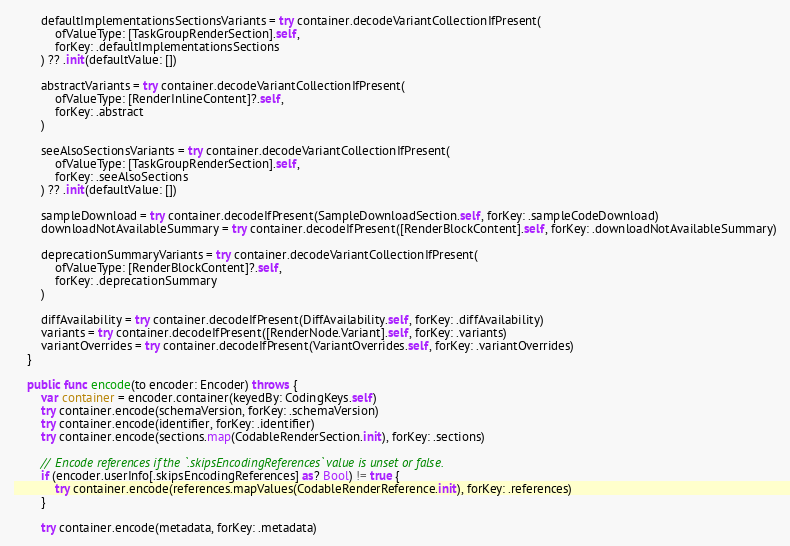Convert code to text. <code><loc_0><loc_0><loc_500><loc_500><_Swift_>        defaultImplementationsSectionsVariants = try container.decodeVariantCollectionIfPresent(
            ofValueType: [TaskGroupRenderSection].self,
            forKey: .defaultImplementationsSections
        ) ?? .init(defaultValue: [])
        
        abstractVariants = try container.decodeVariantCollectionIfPresent(
            ofValueType: [RenderInlineContent]?.self,
            forKey: .abstract
        )
        
        seeAlsoSectionsVariants = try container.decodeVariantCollectionIfPresent(
            ofValueType: [TaskGroupRenderSection].self,
            forKey: .seeAlsoSections
        ) ?? .init(defaultValue: [])
        
        sampleDownload = try container.decodeIfPresent(SampleDownloadSection.self, forKey: .sampleCodeDownload)
        downloadNotAvailableSummary = try container.decodeIfPresent([RenderBlockContent].self, forKey: .downloadNotAvailableSummary)
        
        deprecationSummaryVariants = try container.decodeVariantCollectionIfPresent(
            ofValueType: [RenderBlockContent]?.self,
            forKey: .deprecationSummary
        )
        
        diffAvailability = try container.decodeIfPresent(DiffAvailability.self, forKey: .diffAvailability)
        variants = try container.decodeIfPresent([RenderNode.Variant].self, forKey: .variants)
        variantOverrides = try container.decodeIfPresent(VariantOverrides.self, forKey: .variantOverrides)
    }
    
    public func encode(to encoder: Encoder) throws {
        var container = encoder.container(keyedBy: CodingKeys.self)
        try container.encode(schemaVersion, forKey: .schemaVersion)
        try container.encode(identifier, forKey: .identifier)
        try container.encode(sections.map(CodableRenderSection.init), forKey: .sections)
        
        // Encode references if the `.skipsEncodingReferences` value is unset or false.
        if (encoder.userInfo[.skipsEncodingReferences] as? Bool) != true {
            try container.encode(references.mapValues(CodableRenderReference.init), forKey: .references)
        }
        
        try container.encode(metadata, forKey: .metadata)</code> 